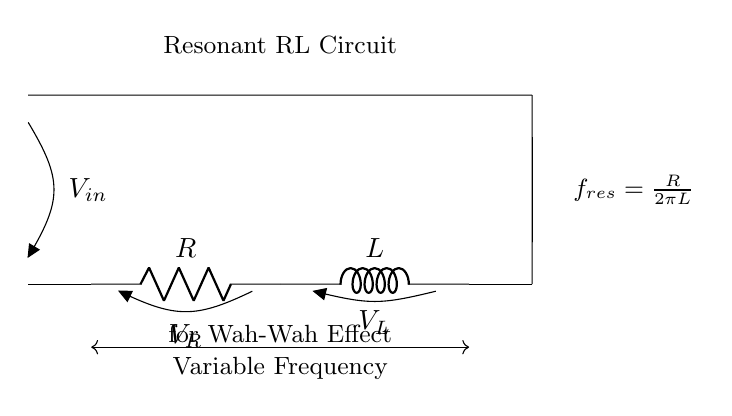What are the components in this circuit? The circuit consists of a resistor and an inductor. The resistor is denoted as R and the inductor as L, which can be seen in the diagram labeled as such.
Answer: Resistor and Inductor What does the variable frequency arrow indicate? The arrow pointing downwards between the resistor and inductor signifies that this circuit allows for variable frequency adjustments, which is essential for creating the wah-wah effect.
Answer: Variable frequency What is the purpose of this RL circuit? The circuit is specifically designed to produce a wah-wah effect, commonly used in guitar pedals to modulate sound and enhance musical expression.
Answer: Wah-wah effect How is the resonant frequency calculated? The resonant frequency is indicated by the formula displayed in the diagram: frequency equals the resistance divided by two pi times the inductance. This relationship provides a clear guideline for adjusting the resonance.
Answer: frequency equals resistance over two pi times inductance What happens to the resonant frequency if resistance increases? If the resistance increases, according to the formula, the resonant frequency will also increase, since frequency is directly proportional to resistance. This means that the effect will shift to higher frequencies.
Answer: Increases What is the significance of the voltage across R and L? The voltages across the resistor and the inductor can indicate how each component is reacting to the input signal. The voltage across R is typically associated with current through it, while the voltage across L relates to the energy stored in the magnetic field. This relationship is crucial in the functioning of the wah-wah effect.
Answer: Reflection of current and energy What type of circuit is this? This is a resonant RL circuit, which is characterized by its configuration of a resistor and an inductor to create oscillations used in effects like wah-wah. It's specifically designed for audio applications.
Answer: Resonant RL circuit 